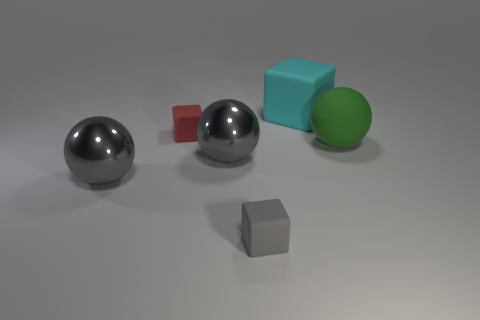What material is the cyan block that is the same size as the green thing? rubber 